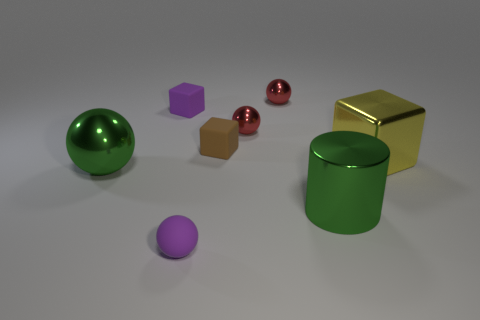Subtract all yellow metallic cubes. How many cubes are left? 2 Add 2 green shiny spheres. How many objects exist? 10 Subtract all red balls. How many balls are left? 2 Subtract all cylinders. How many objects are left? 7 Add 5 big balls. How many big balls are left? 6 Add 5 metallic things. How many metallic things exist? 10 Subtract 1 green cylinders. How many objects are left? 7 Subtract all cyan cylinders. Subtract all gray balls. How many cylinders are left? 1 Subtract all purple blocks. How many green balls are left? 1 Subtract all large spheres. Subtract all purple matte objects. How many objects are left? 5 